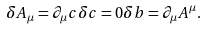<formula> <loc_0><loc_0><loc_500><loc_500>\delta A _ { \mu } = \partial _ { \mu } c \delta c = 0 \delta b = \partial _ { \mu } A ^ { \mu } .</formula> 